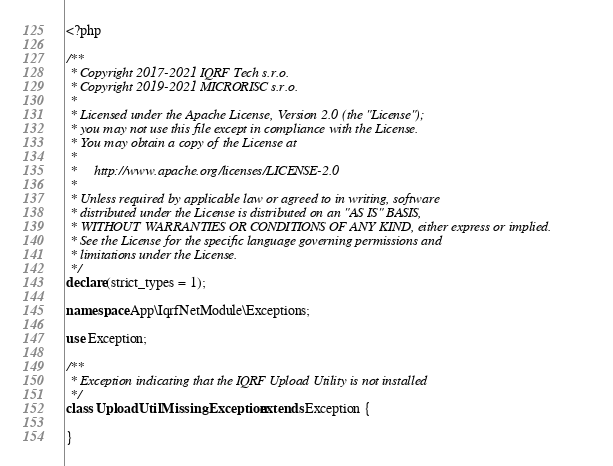Convert code to text. <code><loc_0><loc_0><loc_500><loc_500><_PHP_><?php

/**
 * Copyright 2017-2021 IQRF Tech s.r.o.
 * Copyright 2019-2021 MICRORISC s.r.o.
 *
 * Licensed under the Apache License, Version 2.0 (the "License");
 * you may not use this file except in compliance with the License.
 * You may obtain a copy of the License at
 *
 *     http://www.apache.org/licenses/LICENSE-2.0
 *
 * Unless required by applicable law or agreed to in writing, software
 * distributed under the License is distributed on an "AS IS" BASIS,
 * WITHOUT WARRANTIES OR CONDITIONS OF ANY KIND, either express or implied.
 * See the License for the specific language governing permissions and
 * limitations under the License.
 */
declare(strict_types = 1);

namespace App\IqrfNetModule\Exceptions;

use Exception;

/**
 * Exception indicating that the IQRF Upload Utility is not installed
 */
class UploadUtilMissingException extends Exception {

}
</code> 